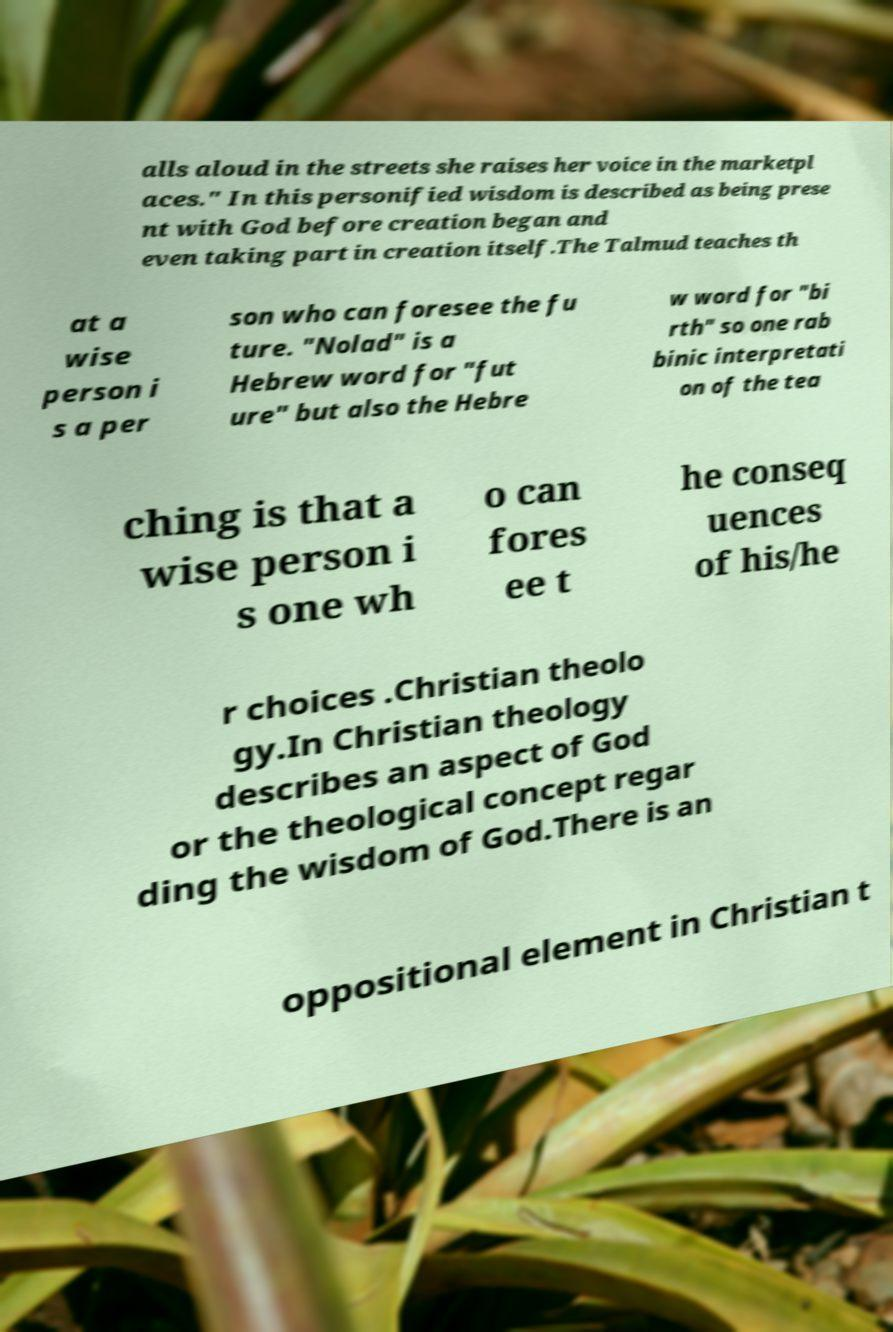Please identify and transcribe the text found in this image. alls aloud in the streets she raises her voice in the marketpl aces." In this personified wisdom is described as being prese nt with God before creation began and even taking part in creation itself.The Talmud teaches th at a wise person i s a per son who can foresee the fu ture. "Nolad" is a Hebrew word for "fut ure" but also the Hebre w word for "bi rth" so one rab binic interpretati on of the tea ching is that a wise person i s one wh o can fores ee t he conseq uences of his/he r choices .Christian theolo gy.In Christian theology describes an aspect of God or the theological concept regar ding the wisdom of God.There is an oppositional element in Christian t 